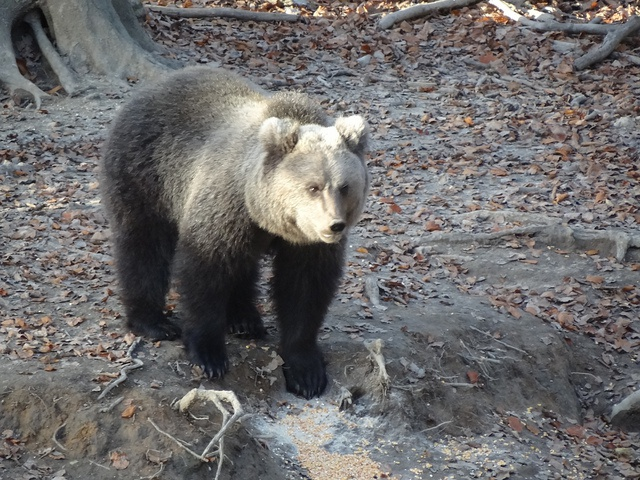Describe the objects in this image and their specific colors. I can see a bear in gray, black, darkgray, and beige tones in this image. 